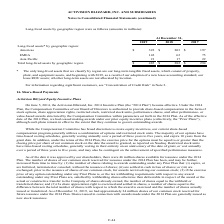According to Activision Blizzard's financial document, What does the company's long-term tangible fixed assets consist of? property, plant, and equipment assets, and beginning with 2019, as a result of our adoption of a new lease accounting standard, our lease ROU assets. The document states: "long-term tangible fixed assets, which consist of property, plant, and equipment assets, and beginning with 2019, as a result of our adoption of a new..." Also, What was the long-lived assets in Americas in 2019? According to the financial document, 322 (in millions). The relevant text states: "Americas $ 322 $ 203 $ 197..." Also, What was the long-lived assets in EMEA in 2019? According to the financial document, 142 (in millions). The relevant text states: "EMEA 142 62 75..." Also, can you calculate: What was the percentage change in the long-lived assets in Americas between 2018 and 2019? To answer this question, I need to perform calculations using the financial data. The calculation is: ($322-$203)/$203, which equals 58.62 (percentage). This is based on the information: "Americas $ 322 $ 203 $ 197 Americas $ 322 $ 203 $ 197..." The key data points involved are: 203, 322. Also, can you calculate: What was the percentage change in the long-lived assets in Asia Pacific between 2018 and 2019? To answer this question, I need to perform calculations using the financial data. The calculation is: (21-17)/17, which equals 23.53 (percentage). This is based on the information: "Asia Pacific 21 17 22 Asia Pacific 21 17 22..." The key data points involved are: 17, 21. Also, can you calculate: What was the change in total long-lived assets by geographical region between 2017 and 2018? Based on the calculation: 282-294, the result is -12 (in millions). This is based on the information: "al long-lived assets by geographic region $ 485 $ 282 $ 294 g-lived assets by geographic region $ 485 $ 282 $ 294..." The key data points involved are: 282, 294. 